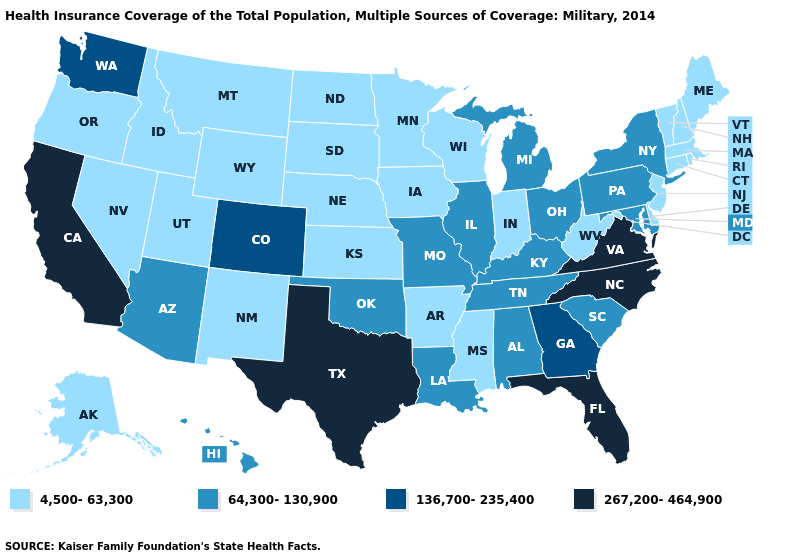What is the highest value in states that border Arizona?
Quick response, please. 267,200-464,900. Name the states that have a value in the range 267,200-464,900?
Give a very brief answer. California, Florida, North Carolina, Texas, Virginia. Does Missouri have a higher value than Michigan?
Keep it brief. No. Among the states that border New York , does Pennsylvania have the lowest value?
Concise answer only. No. Name the states that have a value in the range 267,200-464,900?
Keep it brief. California, Florida, North Carolina, Texas, Virginia. What is the value of Ohio?
Be succinct. 64,300-130,900. What is the value of Hawaii?
Be succinct. 64,300-130,900. What is the value of Montana?
Concise answer only. 4,500-63,300. Does New York have the lowest value in the Northeast?
Short answer required. No. Name the states that have a value in the range 136,700-235,400?
Answer briefly. Colorado, Georgia, Washington. What is the highest value in the MidWest ?
Concise answer only. 64,300-130,900. Does Minnesota have the same value as California?
Be succinct. No. What is the lowest value in the Northeast?
Short answer required. 4,500-63,300. Name the states that have a value in the range 4,500-63,300?
Write a very short answer. Alaska, Arkansas, Connecticut, Delaware, Idaho, Indiana, Iowa, Kansas, Maine, Massachusetts, Minnesota, Mississippi, Montana, Nebraska, Nevada, New Hampshire, New Jersey, New Mexico, North Dakota, Oregon, Rhode Island, South Dakota, Utah, Vermont, West Virginia, Wisconsin, Wyoming. What is the lowest value in states that border Arkansas?
Write a very short answer. 4,500-63,300. 